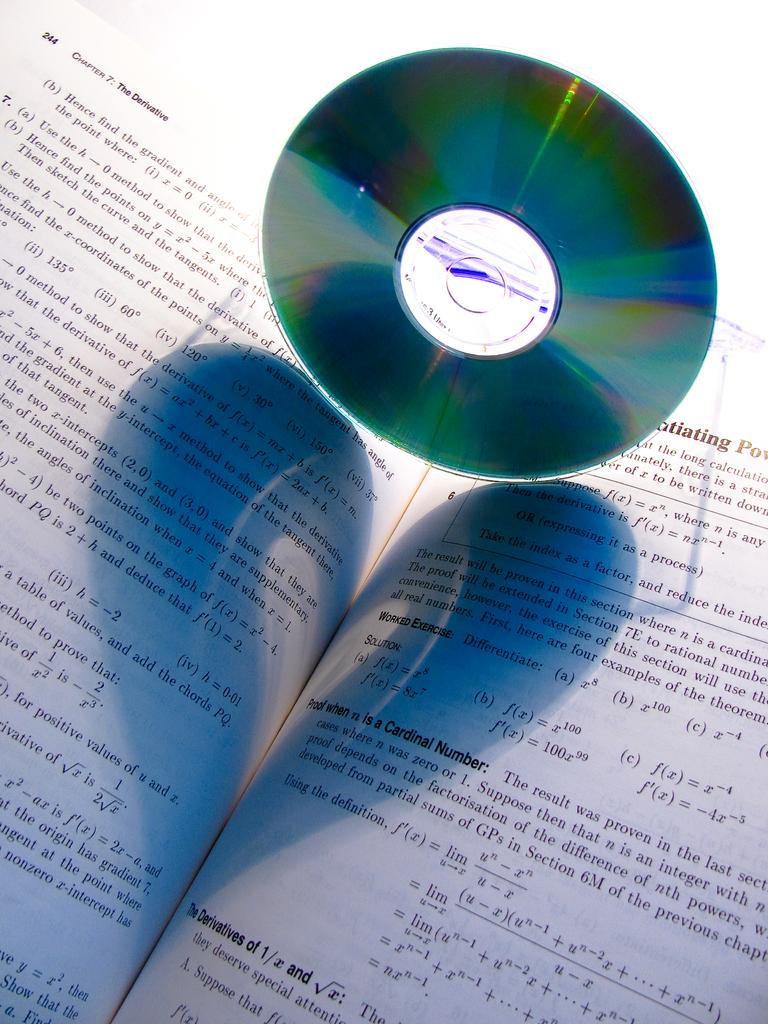<image>
Present a compact description of the photo's key features. a book that says 'chapter 7: the derivative' on it 